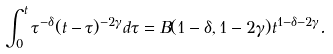Convert formula to latex. <formula><loc_0><loc_0><loc_500><loc_500>\int _ { 0 } ^ { t } \tau ^ { - \delta } ( t - \tau ) ^ { - 2 \gamma } d \tau = B ( 1 - \delta , 1 - 2 \gamma ) t ^ { 1 - \delta - 2 \gamma } .</formula> 